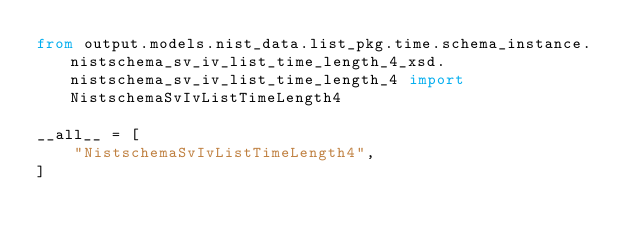<code> <loc_0><loc_0><loc_500><loc_500><_Python_>from output.models.nist_data.list_pkg.time.schema_instance.nistschema_sv_iv_list_time_length_4_xsd.nistschema_sv_iv_list_time_length_4 import NistschemaSvIvListTimeLength4

__all__ = [
    "NistschemaSvIvListTimeLength4",
]
</code> 